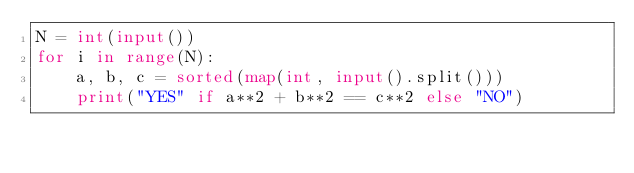Convert code to text. <code><loc_0><loc_0><loc_500><loc_500><_Python_>N = int(input())
for i in range(N):
    a, b, c = sorted(map(int, input().split()))
    print("YES" if a**2 + b**2 == c**2 else "NO")
</code> 